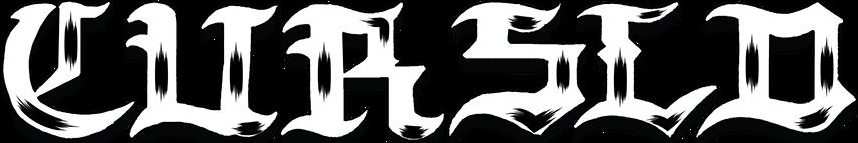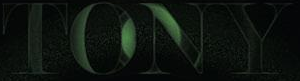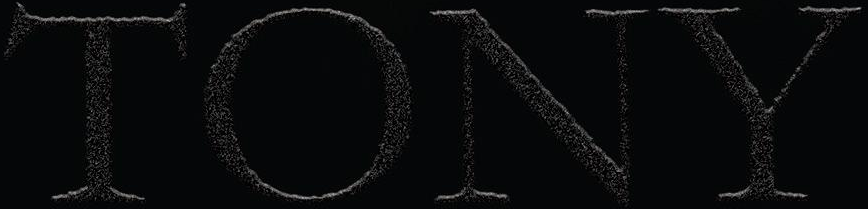Transcribe the words shown in these images in order, separated by a semicolon. CURSLD; TONY; TONY 